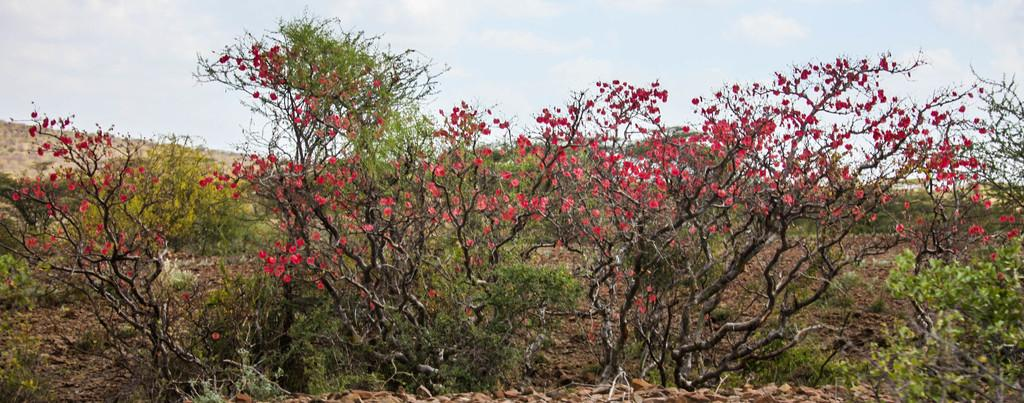What type of vegetation can be seen in the image? There are trees in the image. What are the trees doing in the image? The trees have flowers. What color are the flowers on the trees? The flowers are red in color. What can be seen in the background of the image? The sky is visible in the background of the image. How did your aunt's test affect the flowers in the image? There is no mention of an aunt or a test in the image, so it is not possible to determine any effect on the flowers. 